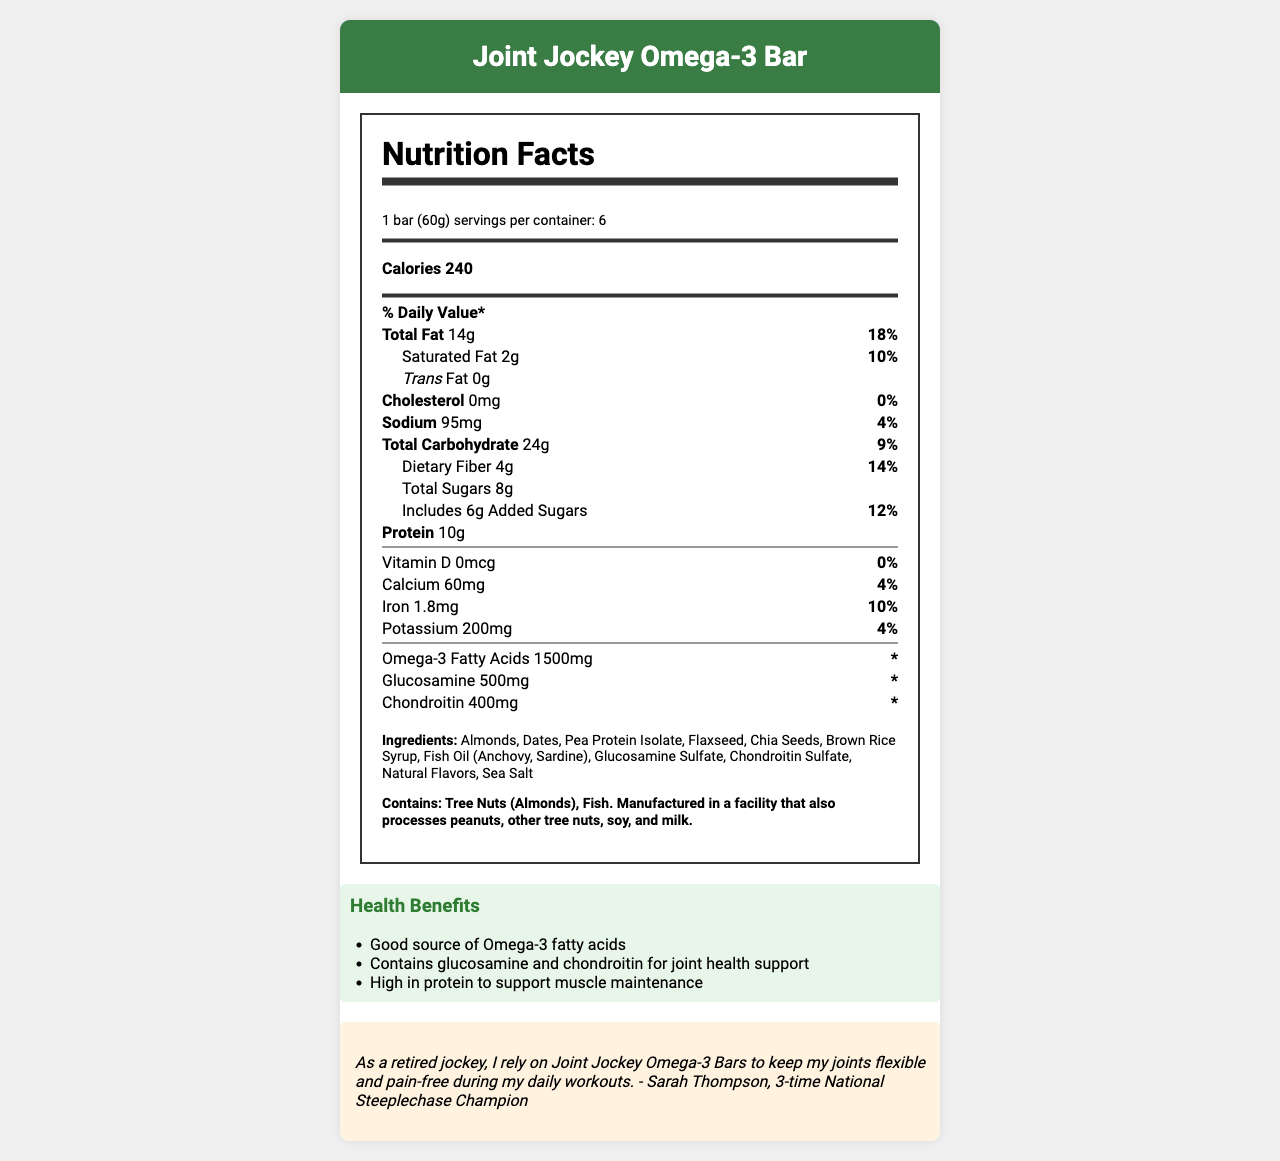what is the serving size? The serving size is mentioned at the beginning of the Nutrition Facts section, which states "serving size: 1 bar (60g)".
Answer: 1 bar (60g) how many servings are in one container? It is specified in the Nutrition Facts section as "servings per container: 6".
Answer: 6 what is the amount of protein per serving? In the Nutrition Facts section, it lists "Protein 10g".
Answer: 10g how much calcium does one bar contain? The Nutrition Facts section specifies "Calcium 60mg".
Answer: 60mg what is the daily value percentage for iron in one bar? The percentage daily value for iron is listed as "Iron 10%" in the Nutrition Facts section.
Answer: 10% which of the following allergies does this product contain? A. Peanuts B. Tree Nuts C. Soy D. Milk The allergen information states "Contains: Tree Nuts (Almonds), Fish."
Answer: B what is the total amount of sugars in one bar? A. 6g B. 8g C. 4g D. 12g The Nutrition Facts section reports "Total Sugars 8g".
Answer: B does the product contain any added sugars? The Nutrition Facts section shows "Includes 6g Added Sugars".
Answer: Yes is there any cholesterol in the Joint Jockey Omega-3 Bar? The Nutrition Facts section lists "Cholesterol 0mg".
Answer: No summarize the key benefits of the Joint Jockey Omega-3 Bar. This summary captures the main elements found across the Nutrition Facts, ingredient list, health claims, and athlete testimonial sections of the document.
Answer: The Joint Jockey Omega-3 Bar is designed specifically for retired athletes, offering significant amounts of omega-3 fatty acids and glucosamine for joint health, high protein content for muscle maintenance, and is made from natural ingredients like almonds and dates. It also includes athlete testimonials endorsing its effectiveness for joint health and flexibility. what is the source of omega-3 fatty acids in the bar? The Nutrition Facts list the amount of omega-3 fatty acids, but the exact ingredient source is not specified. However, it is implied it may come from fish oil listed in the ingredients.
Answer: Not enough information what is the total fat content in one bar? The Nutrition Facts section lists "Total Fat 14g".
Answer: 14g how much glucosamine is in one bar? It is specified in the Nutrition Facts under a separate section for glucosamine as "Glucosamine 500mg".
Answer: 500mg does the product contain any Vitamin D? The Nutrition Facts section lists "Vitamin D 0mcg".
Answer: No 